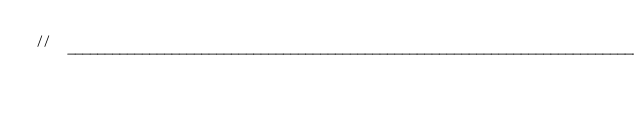Convert code to text. <code><loc_0><loc_0><loc_500><loc_500><_C#_>// ------------------------------------------------------------------------------</code> 